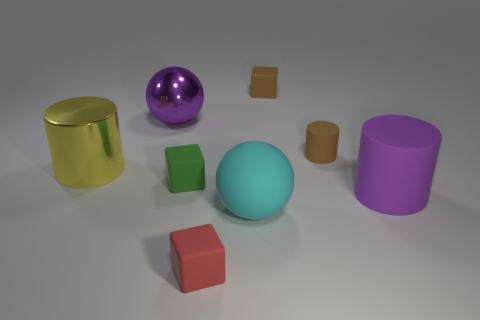Add 1 large rubber cylinders. How many objects exist? 9 Subtract all blocks. How many objects are left? 5 Subtract 0 blue blocks. How many objects are left? 8 Subtract all small red matte spheres. Subtract all big yellow metallic things. How many objects are left? 7 Add 6 large yellow things. How many large yellow things are left? 7 Add 4 purple rubber cylinders. How many purple rubber cylinders exist? 5 